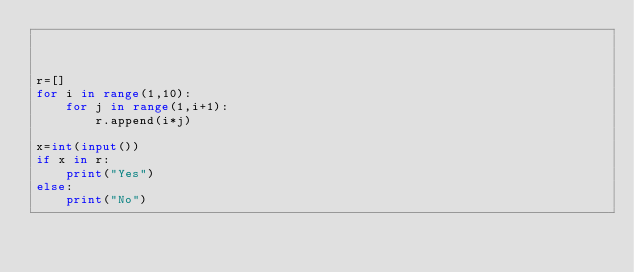Convert code to text. <code><loc_0><loc_0><loc_500><loc_500><_Python_>


r=[]
for i in range(1,10):
    for j in range(1,i+1):
        r.append(i*j)

x=int(input())
if x in r:
    print("Yes")
else:
    print("No")



</code> 